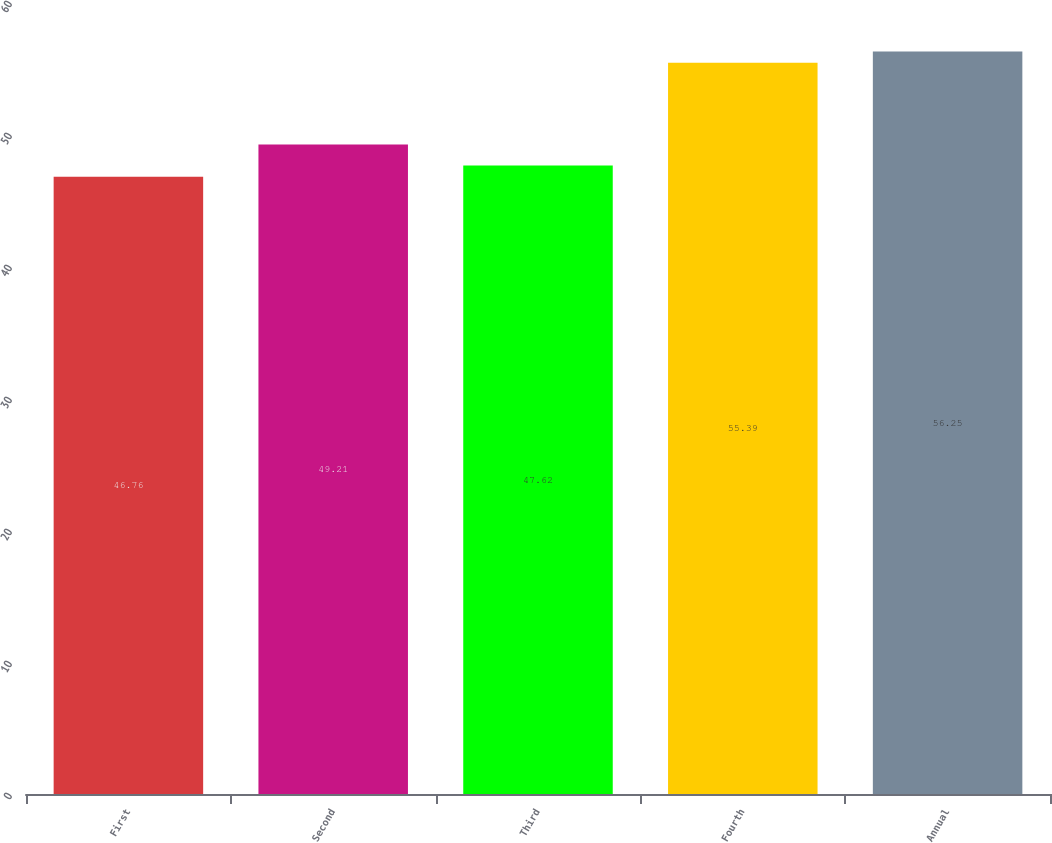<chart> <loc_0><loc_0><loc_500><loc_500><bar_chart><fcel>First<fcel>Second<fcel>Third<fcel>Fourth<fcel>Annual<nl><fcel>46.76<fcel>49.21<fcel>47.62<fcel>55.39<fcel>56.25<nl></chart> 